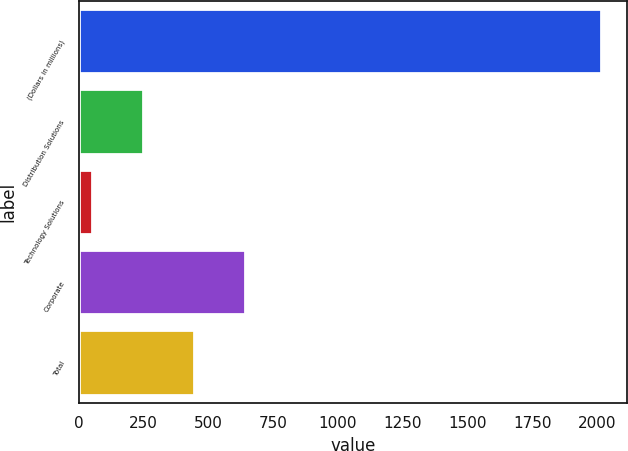Convert chart. <chart><loc_0><loc_0><loc_500><loc_500><bar_chart><fcel>(Dollars in millions)<fcel>Distribution Solutions<fcel>Technology Solutions<fcel>Corporate<fcel>Total<nl><fcel>2015<fcel>246.5<fcel>50<fcel>639.5<fcel>443<nl></chart> 